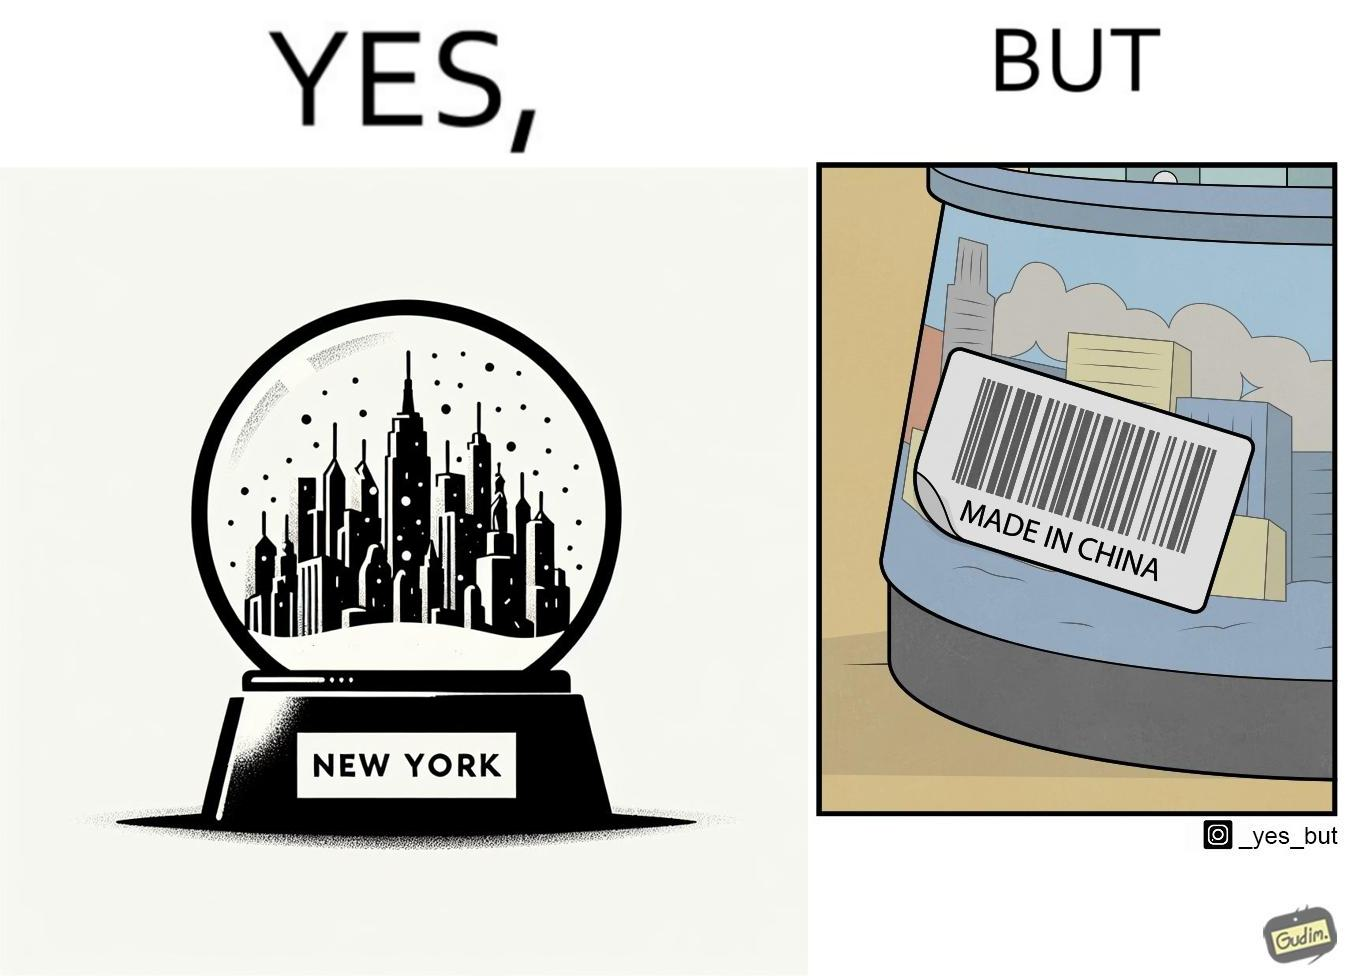What do you see in each half of this image? In the left part of the image: A snowglobe that says 'New York' In the right part of the image: Made in china' label on the snowglobe 